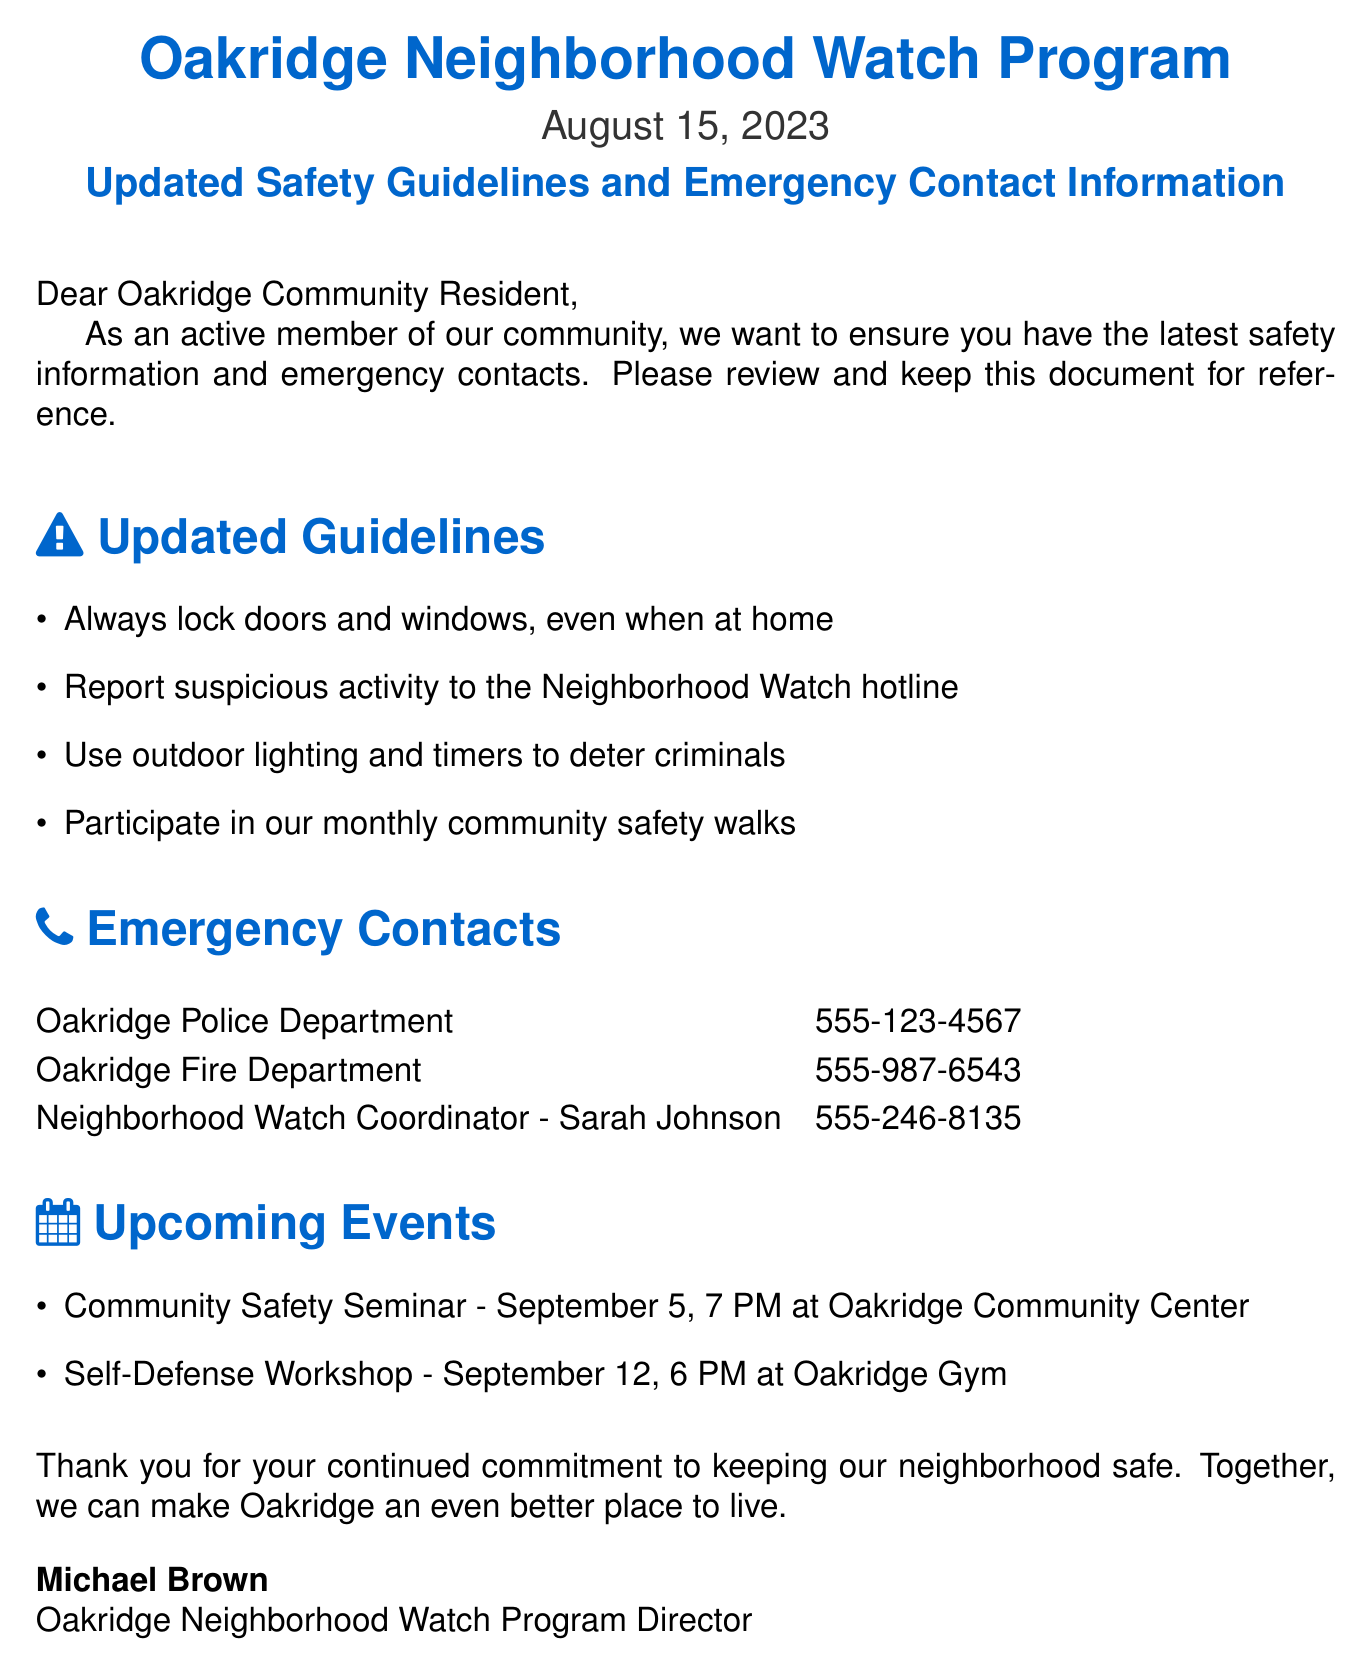What is the date of the document? The date of the document is clearly stated in the second line after the title.
Answer: August 15, 2023 Who is the Neighborhood Watch Coordinator? The document lists names and contact information, including the Neighborhood Watch Coordinator.
Answer: Sarah Johnson What is the contact number for the Oakridge Police Department? The contact number is explicitly provided in the emergency contacts section of the document.
Answer: 555-123-4567 When is the Community Safety Seminar? The event is listed, including the date and time, in the upcoming events section.
Answer: September 5, 7 PM What should residents do if they see suspicious activity? The updated guidelines instruct residents on what actions to take.
Answer: Report to the Neighborhood Watch hotline What type of workshop is being held on September 12? The upcoming events section provides the type of workshop and its date.
Answer: Self-Defense Workshop What is the purpose of outdoor lighting according to the guidelines? The guidelines explain the benefits of outdoor lighting in preventing crime.
Answer: Deter criminals How many safety walks does the document encourage participating in? The document mentions community safety walks without specifying a number, implying ongoing participation.
Answer: Monthly 